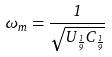<formula> <loc_0><loc_0><loc_500><loc_500>\omega _ { m } = \frac { 1 } { \sqrt { U _ { \frac { 1 } { 9 } } C _ { \frac { 1 } { 9 } } } }</formula> 